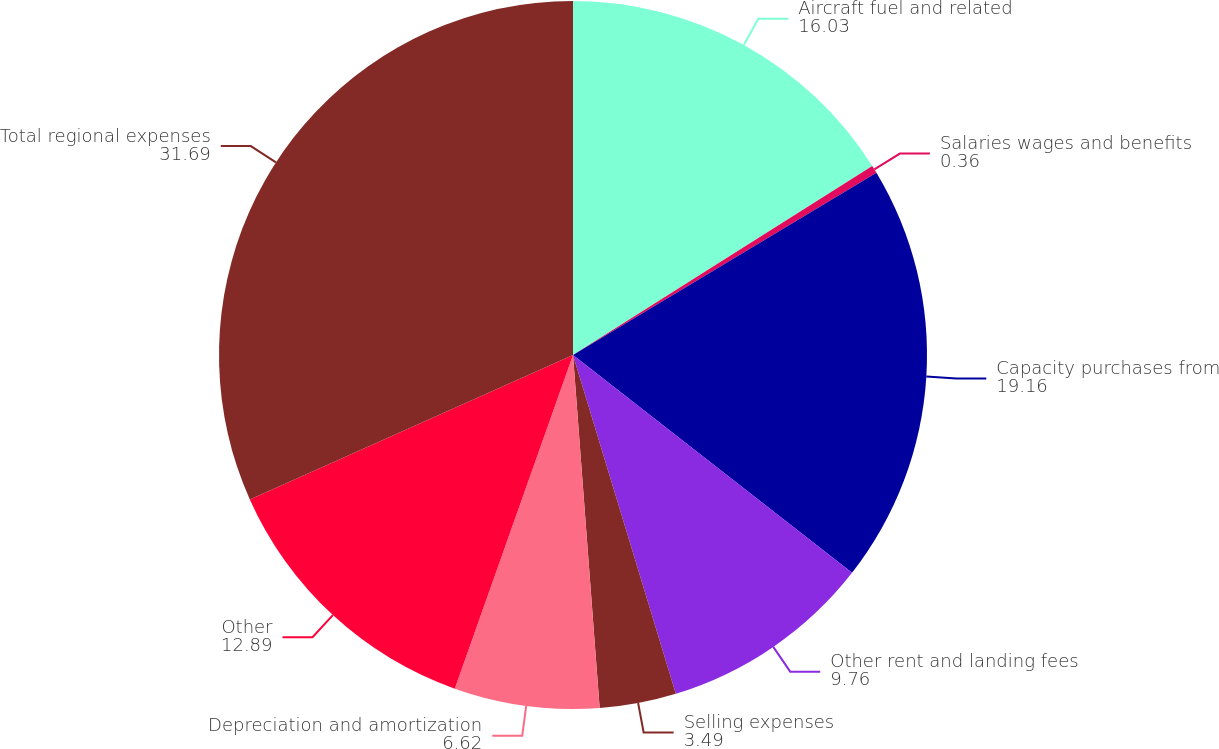Convert chart to OTSL. <chart><loc_0><loc_0><loc_500><loc_500><pie_chart><fcel>Aircraft fuel and related<fcel>Salaries wages and benefits<fcel>Capacity purchases from<fcel>Other rent and landing fees<fcel>Selling expenses<fcel>Depreciation and amortization<fcel>Other<fcel>Total regional expenses<nl><fcel>16.03%<fcel>0.36%<fcel>19.16%<fcel>9.76%<fcel>3.49%<fcel>6.62%<fcel>12.89%<fcel>31.69%<nl></chart> 